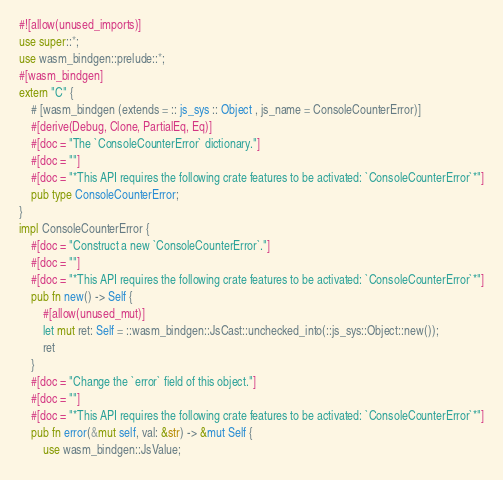<code> <loc_0><loc_0><loc_500><loc_500><_Rust_>#![allow(unused_imports)]
use super::*;
use wasm_bindgen::prelude::*;
#[wasm_bindgen]
extern "C" {
    # [wasm_bindgen (extends = :: js_sys :: Object , js_name = ConsoleCounterError)]
    #[derive(Debug, Clone, PartialEq, Eq)]
    #[doc = "The `ConsoleCounterError` dictionary."]
    #[doc = ""]
    #[doc = "*This API requires the following crate features to be activated: `ConsoleCounterError`*"]
    pub type ConsoleCounterError;
}
impl ConsoleCounterError {
    #[doc = "Construct a new `ConsoleCounterError`."]
    #[doc = ""]
    #[doc = "*This API requires the following crate features to be activated: `ConsoleCounterError`*"]
    pub fn new() -> Self {
        #[allow(unused_mut)]
        let mut ret: Self = ::wasm_bindgen::JsCast::unchecked_into(::js_sys::Object::new());
        ret
    }
    #[doc = "Change the `error` field of this object."]
    #[doc = ""]
    #[doc = "*This API requires the following crate features to be activated: `ConsoleCounterError`*"]
    pub fn error(&mut self, val: &str) -> &mut Self {
        use wasm_bindgen::JsValue;</code> 